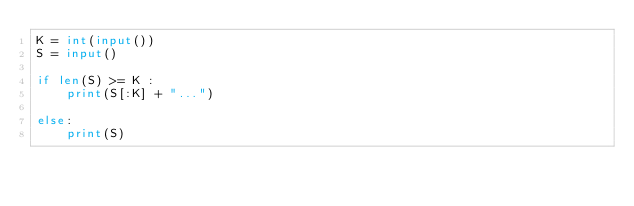Convert code to text. <code><loc_0><loc_0><loc_500><loc_500><_Python_>K = int(input())
S = input()

if len(S) >= K :
    print(S[:K] + "...")

else:
    print(S)</code> 